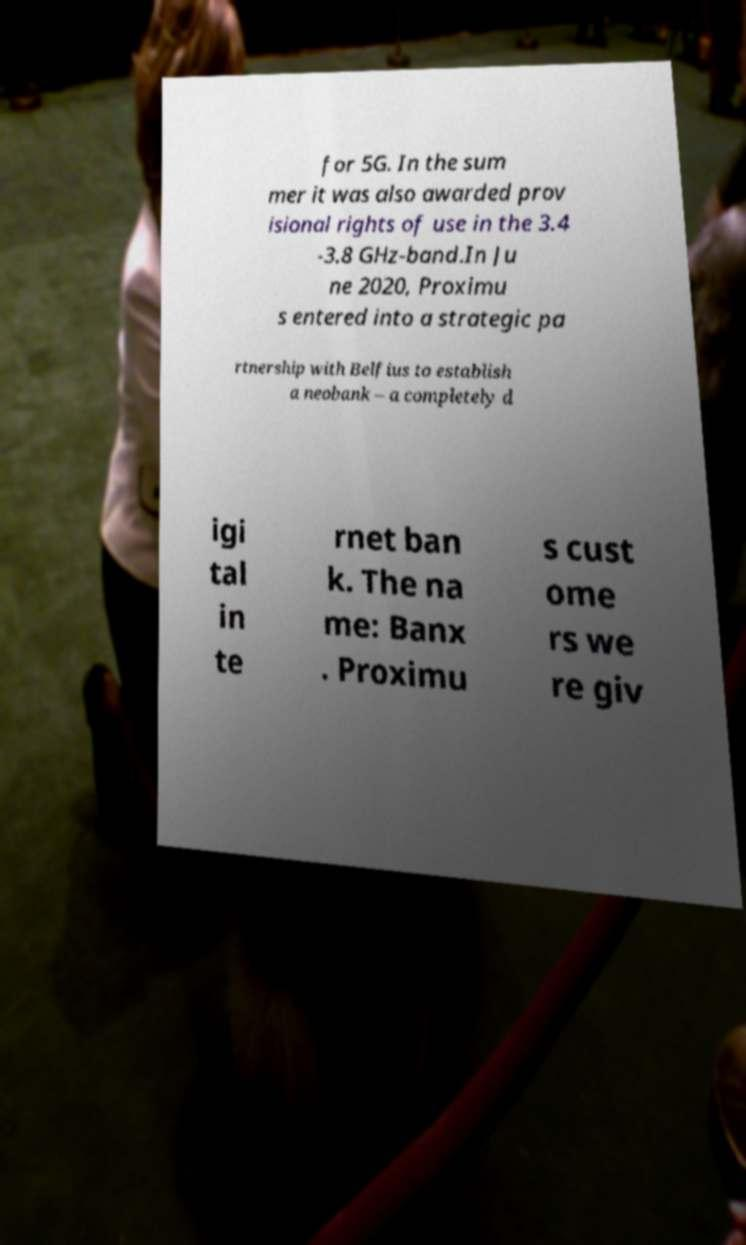I need the written content from this picture converted into text. Can you do that? for 5G. In the sum mer it was also awarded prov isional rights of use in the 3.4 -3.8 GHz-band.In Ju ne 2020, Proximu s entered into a strategic pa rtnership with Belfius to establish a neobank – a completely d igi tal in te rnet ban k. The na me: Banx . Proximu s cust ome rs we re giv 